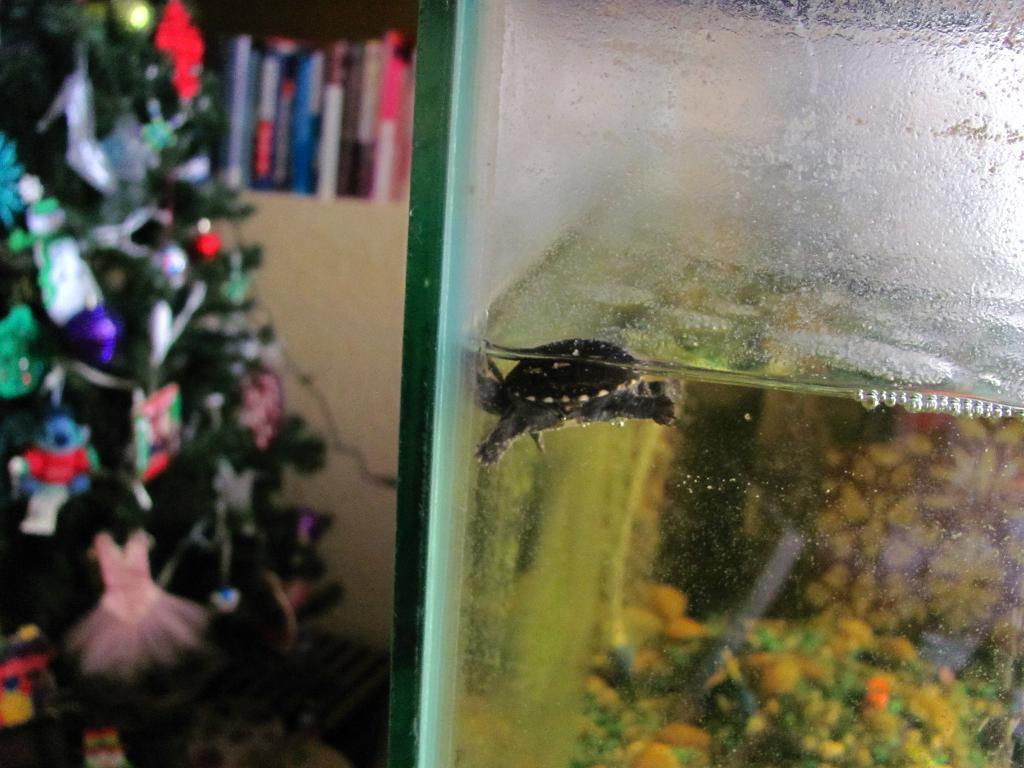What type of animal can be seen in the water in the image? There is a reptile in the water in the image. What is located on the left side of the image? There is a Christmas tree on the left side of the image. What other objects can be seen in the image? There are books visible in the image. What type of pies are being sold near the Christmas tree? There are no pies present in the image. What is the price of the reptile in the water? The image does not provide any information about the price of the reptile. 